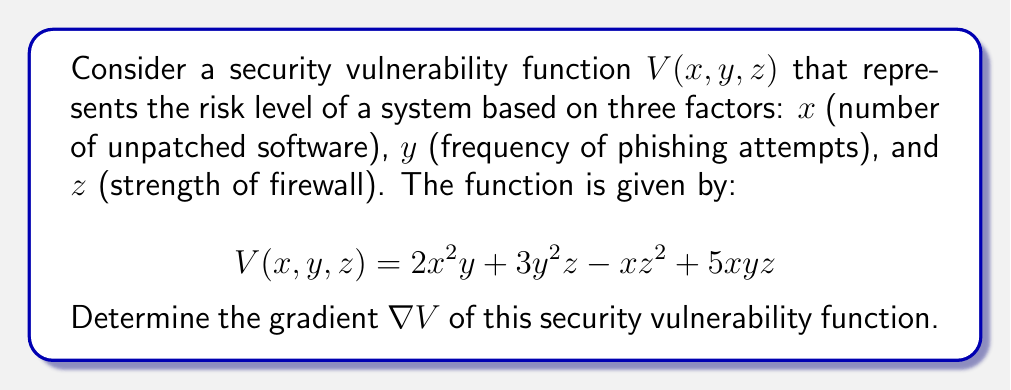Solve this math problem. To find the gradient of the security vulnerability function $V(x, y, z)$, we need to calculate the partial derivatives with respect to each variable:

1. Calculate $\frac{\partial V}{\partial x}$:
   $$\frac{\partial V}{\partial x} = 4xy - z^2 + 5yz$$

2. Calculate $\frac{\partial V}{\partial y}$:
   $$\frac{\partial V}{\partial y} = 2x^2 + 6yz + 5xz$$

3. Calculate $\frac{\partial V}{\partial z}$:
   $$\frac{\partial V}{\partial z} = 3y^2 - 2xz + 5xy$$

The gradient $\nabla V$ is a vector of these partial derivatives:

$$\nabla V = \left(\frac{\partial V}{\partial x}, \frac{\partial V}{\partial y}, \frac{\partial V}{\partial z}\right)$$

Substituting the calculated partial derivatives:

$$\nabla V = (4xy - z^2 + 5yz, 2x^2 + 6yz + 5xz, 3y^2 - 2xz + 5xy)$$

This gradient vector represents the direction of steepest increase in the security vulnerability function, which can help identify the most critical factors affecting system security.
Answer: $$\nabla V = (4xy - z^2 + 5yz, 2x^2 + 6yz + 5xz, 3y^2 - 2xz + 5xy)$$ 